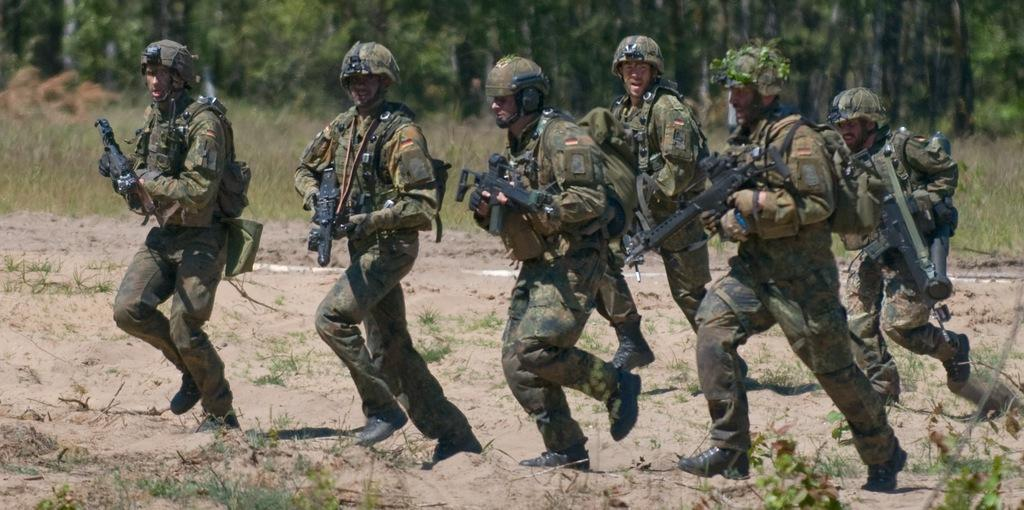Who or what is present in the image? There are people in the image. What are the people doing in the image? The people are standing and holding rifles in their hands. What protective gear are the people wearing? The people are wearing helmets. What can be seen in the background of the image? There are trees visible in the background of the image. What type of beef can be seen cooking on a grill in the image? There is no beef or grill present in the image; it features people standing with rifles and wearing helmets. Can you tell me how many people are walking along the seashore in the image? There is no seashore or walking people present in the image; it features people standing with rifles and wearing helmets. 